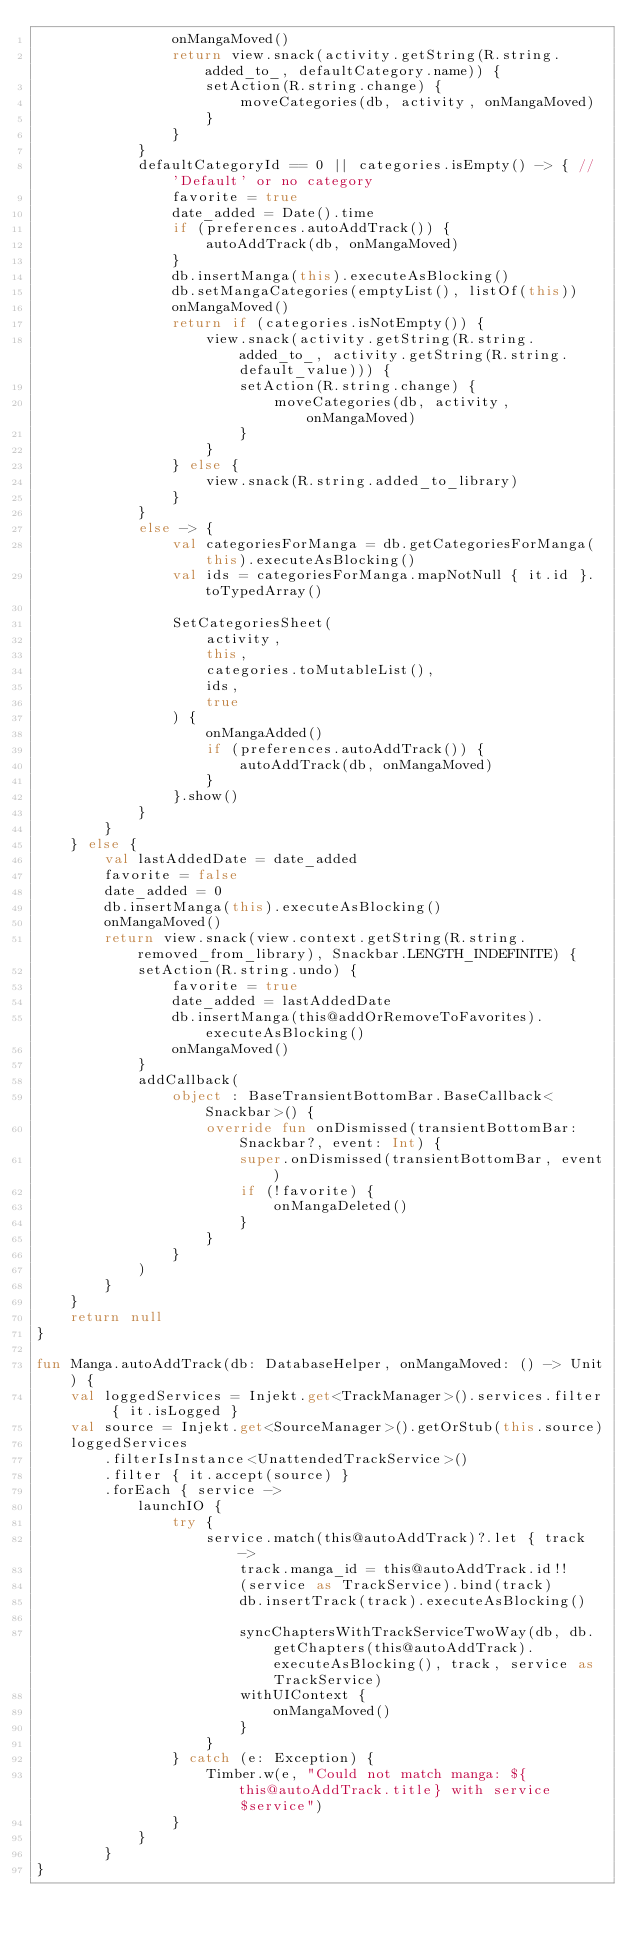<code> <loc_0><loc_0><loc_500><loc_500><_Kotlin_>                onMangaMoved()
                return view.snack(activity.getString(R.string.added_to_, defaultCategory.name)) {
                    setAction(R.string.change) {
                        moveCategories(db, activity, onMangaMoved)
                    }
                }
            }
            defaultCategoryId == 0 || categories.isEmpty() -> { // 'Default' or no category
                favorite = true
                date_added = Date().time
                if (preferences.autoAddTrack()) {
                    autoAddTrack(db, onMangaMoved)
                }
                db.insertManga(this).executeAsBlocking()
                db.setMangaCategories(emptyList(), listOf(this))
                onMangaMoved()
                return if (categories.isNotEmpty()) {
                    view.snack(activity.getString(R.string.added_to_, activity.getString(R.string.default_value))) {
                        setAction(R.string.change) {
                            moveCategories(db, activity, onMangaMoved)
                        }
                    }
                } else {
                    view.snack(R.string.added_to_library)
                }
            }
            else -> {
                val categoriesForManga = db.getCategoriesForManga(this).executeAsBlocking()
                val ids = categoriesForManga.mapNotNull { it.id }.toTypedArray()

                SetCategoriesSheet(
                    activity,
                    this,
                    categories.toMutableList(),
                    ids,
                    true
                ) {
                    onMangaAdded()
                    if (preferences.autoAddTrack()) {
                        autoAddTrack(db, onMangaMoved)
                    }
                }.show()
            }
        }
    } else {
        val lastAddedDate = date_added
        favorite = false
        date_added = 0
        db.insertManga(this).executeAsBlocking()
        onMangaMoved()
        return view.snack(view.context.getString(R.string.removed_from_library), Snackbar.LENGTH_INDEFINITE) {
            setAction(R.string.undo) {
                favorite = true
                date_added = lastAddedDate
                db.insertManga(this@addOrRemoveToFavorites).executeAsBlocking()
                onMangaMoved()
            }
            addCallback(
                object : BaseTransientBottomBar.BaseCallback<Snackbar>() {
                    override fun onDismissed(transientBottomBar: Snackbar?, event: Int) {
                        super.onDismissed(transientBottomBar, event)
                        if (!favorite) {
                            onMangaDeleted()
                        }
                    }
                }
            )
        }
    }
    return null
}

fun Manga.autoAddTrack(db: DatabaseHelper, onMangaMoved: () -> Unit) {
    val loggedServices = Injekt.get<TrackManager>().services.filter { it.isLogged }
    val source = Injekt.get<SourceManager>().getOrStub(this.source)
    loggedServices
        .filterIsInstance<UnattendedTrackService>()
        .filter { it.accept(source) }
        .forEach { service ->
            launchIO {
                try {
                    service.match(this@autoAddTrack)?.let { track ->
                        track.manga_id = this@autoAddTrack.id!!
                        (service as TrackService).bind(track)
                        db.insertTrack(track).executeAsBlocking()

                        syncChaptersWithTrackServiceTwoWay(db, db.getChapters(this@autoAddTrack).executeAsBlocking(), track, service as TrackService)
                        withUIContext {
                            onMangaMoved()
                        }
                    }
                } catch (e: Exception) {
                    Timber.w(e, "Could not match manga: ${this@autoAddTrack.title} with service $service")
                }
            }
        }
}
</code> 